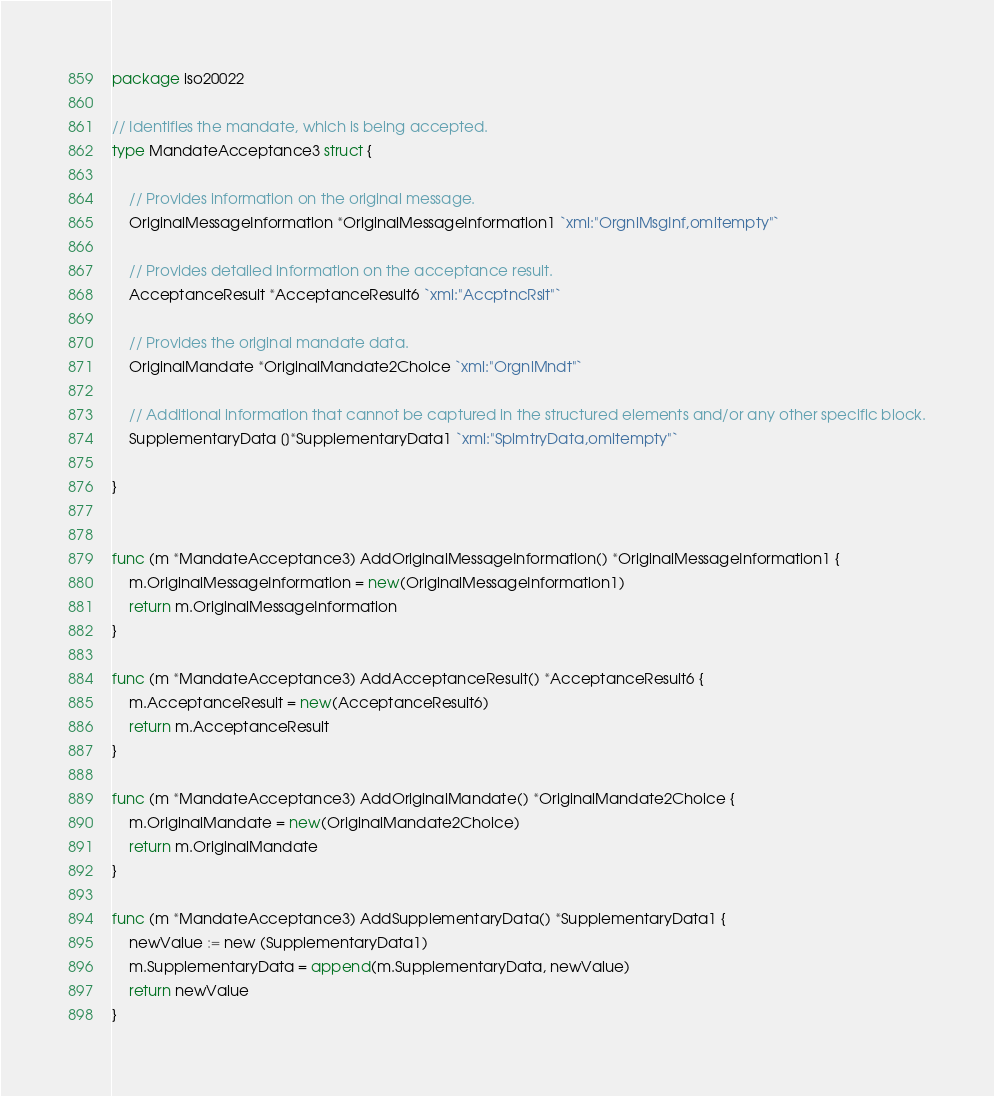<code> <loc_0><loc_0><loc_500><loc_500><_Go_>package iso20022

// Identifies the mandate, which is being accepted.
type MandateAcceptance3 struct {

	// Provides information on the original message.
	OriginalMessageInformation *OriginalMessageInformation1 `xml:"OrgnlMsgInf,omitempty"`

	// Provides detailed information on the acceptance result.
	AcceptanceResult *AcceptanceResult6 `xml:"AccptncRslt"`

	// Provides the original mandate data.
	OriginalMandate *OriginalMandate2Choice `xml:"OrgnlMndt"`

	// Additional information that cannot be captured in the structured elements and/or any other specific block.
	SupplementaryData []*SupplementaryData1 `xml:"SplmtryData,omitempty"`

}


func (m *MandateAcceptance3) AddOriginalMessageInformation() *OriginalMessageInformation1 {
	m.OriginalMessageInformation = new(OriginalMessageInformation1)
	return m.OriginalMessageInformation
}

func (m *MandateAcceptance3) AddAcceptanceResult() *AcceptanceResult6 {
	m.AcceptanceResult = new(AcceptanceResult6)
	return m.AcceptanceResult
}

func (m *MandateAcceptance3) AddOriginalMandate() *OriginalMandate2Choice {
	m.OriginalMandate = new(OriginalMandate2Choice)
	return m.OriginalMandate
}

func (m *MandateAcceptance3) AddSupplementaryData() *SupplementaryData1 {
	newValue := new (SupplementaryData1)
	m.SupplementaryData = append(m.SupplementaryData, newValue)
	return newValue
}

</code> 